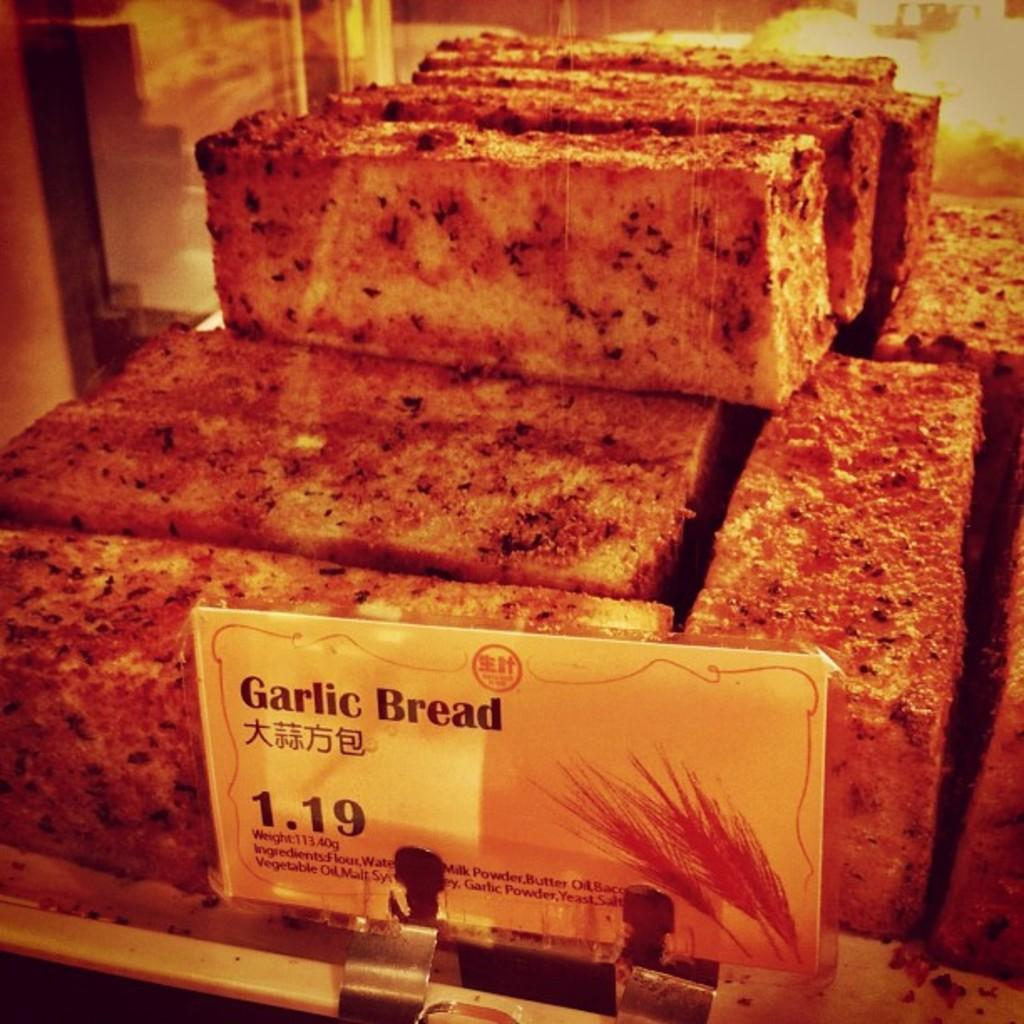What type of food is visible on the tray in the image? There are slices of garlic bread on a tray. What information is displayed near the garlic bread? There is a price board in front of the garlic bread. How many flies are sitting on the garlic bread in the image? There are no flies visible on the garlic bread in the image. What type of ground is the garlic bread resting on in the image? The garlic bread is resting on a tray, not directly on the ground. 